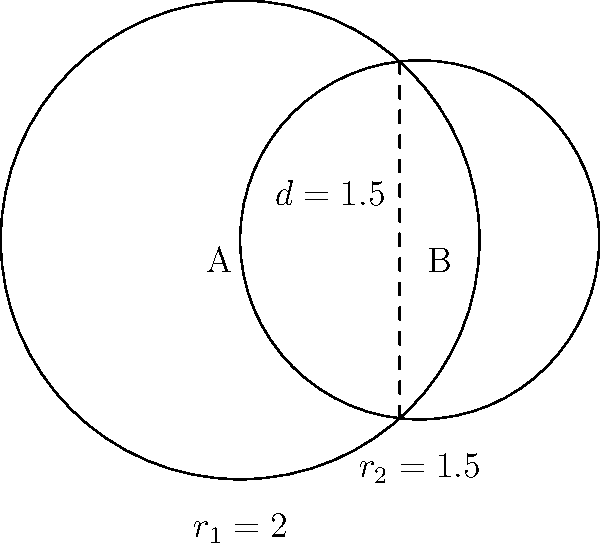Two circles represent the nutrient profiles of different protein-rich foods. Circle A has a radius of 2 units, and Circle B has a radius of 1.5 units. The centers of the circles are 1.5 units apart. Calculate the area of overlap between these two circles, which represents the common nutrients shared by both foods. To find the area of overlap between two circles, we can use the formula for the area of intersection:

1) First, calculate the distance $x$ from the center of each circle to the chord of intersection:

   For Circle A: $x_1 = \frac{r_1^2 - r_2^2 + d^2}{2d} = \frac{2^2 - 1.5^2 + 1.5^2}{2(1.5)} = \frac{4 - 2.25 + 2.25}{3} = \frac{4}{3}$

   For Circle B: $x_2 = d - x_1 = 1.5 - \frac{4}{3} = \frac{1}{6}$

2) Calculate the angle $\theta$ (in radians) for each circle:

   $\theta_1 = 2 \arccos(\frac{x_1}{r_1}) = 2 \arccos(\frac{4/3}{2}) = 2 \arccos(\frac{2}{3})$
   $\theta_2 = 2 \arccos(\frac{x_2}{r_2}) = 2 \arccos(\frac{1/6}{1.5}) = 2 \arccos(\frac{1}{9})$

3) The area of overlap is the sum of the two circular segments:

   Area = $\frac{1}{2}r_1^2(\theta_1 - \sin\theta_1) + \frac{1}{2}r_2^2(\theta_2 - \sin\theta_2)$

4) Substituting the values:

   Area = $\frac{1}{2}(2^2)(2\arccos(\frac{2}{3}) - \sin(2\arccos(\frac{2}{3}))) + \frac{1}{2}(1.5^2)(2\arccos(\frac{1}{9}) - \sin(2\arccos(\frac{1}{9})))$

5) Simplifying:

   Area ≈ 2.721 square units
Answer: 2.721 square units 